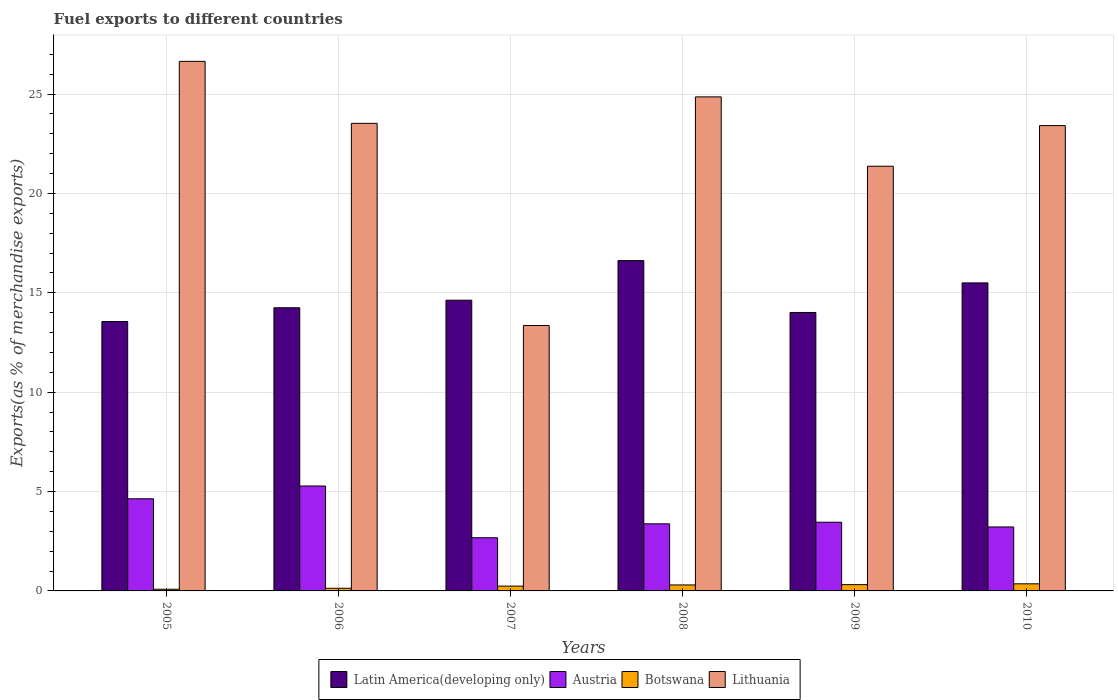How many groups of bars are there?
Your answer should be very brief. 6. Are the number of bars on each tick of the X-axis equal?
Provide a succinct answer. Yes. What is the label of the 4th group of bars from the left?
Offer a very short reply. 2008. In how many cases, is the number of bars for a given year not equal to the number of legend labels?
Make the answer very short. 0. What is the percentage of exports to different countries in Lithuania in 2005?
Offer a terse response. 26.65. Across all years, what is the maximum percentage of exports to different countries in Lithuania?
Your response must be concise. 26.65. Across all years, what is the minimum percentage of exports to different countries in Botswana?
Your answer should be very brief. 0.09. What is the total percentage of exports to different countries in Lithuania in the graph?
Your answer should be compact. 133.18. What is the difference between the percentage of exports to different countries in Botswana in 2007 and that in 2010?
Offer a terse response. -0.12. What is the difference between the percentage of exports to different countries in Botswana in 2008 and the percentage of exports to different countries in Austria in 2009?
Provide a succinct answer. -3.16. What is the average percentage of exports to different countries in Botswana per year?
Ensure brevity in your answer.  0.24. In the year 2005, what is the difference between the percentage of exports to different countries in Lithuania and percentage of exports to different countries in Latin America(developing only)?
Your answer should be very brief. 13.09. In how many years, is the percentage of exports to different countries in Latin America(developing only) greater than 17 %?
Keep it short and to the point. 0. What is the ratio of the percentage of exports to different countries in Latin America(developing only) in 2007 to that in 2009?
Offer a very short reply. 1.04. Is the percentage of exports to different countries in Botswana in 2005 less than that in 2006?
Offer a very short reply. Yes. What is the difference between the highest and the second highest percentage of exports to different countries in Lithuania?
Your answer should be very brief. 1.79. What is the difference between the highest and the lowest percentage of exports to different countries in Austria?
Offer a very short reply. 2.6. Is the sum of the percentage of exports to different countries in Botswana in 2008 and 2010 greater than the maximum percentage of exports to different countries in Lithuania across all years?
Your answer should be compact. No. Is it the case that in every year, the sum of the percentage of exports to different countries in Botswana and percentage of exports to different countries in Latin America(developing only) is greater than the sum of percentage of exports to different countries in Lithuania and percentage of exports to different countries in Austria?
Make the answer very short. No. What does the 1st bar from the left in 2006 represents?
Your answer should be compact. Latin America(developing only). What does the 2nd bar from the right in 2005 represents?
Provide a short and direct response. Botswana. How many bars are there?
Ensure brevity in your answer.  24. What is the difference between two consecutive major ticks on the Y-axis?
Make the answer very short. 5. Are the values on the major ticks of Y-axis written in scientific E-notation?
Your answer should be compact. No. Does the graph contain grids?
Keep it short and to the point. Yes. How are the legend labels stacked?
Your response must be concise. Horizontal. What is the title of the graph?
Your answer should be very brief. Fuel exports to different countries. What is the label or title of the Y-axis?
Your answer should be very brief. Exports(as % of merchandise exports). What is the Exports(as % of merchandise exports) of Latin America(developing only) in 2005?
Your answer should be very brief. 13.56. What is the Exports(as % of merchandise exports) of Austria in 2005?
Your answer should be compact. 4.64. What is the Exports(as % of merchandise exports) of Botswana in 2005?
Your answer should be very brief. 0.09. What is the Exports(as % of merchandise exports) of Lithuania in 2005?
Give a very brief answer. 26.65. What is the Exports(as % of merchandise exports) in Latin America(developing only) in 2006?
Provide a short and direct response. 14.25. What is the Exports(as % of merchandise exports) in Austria in 2006?
Ensure brevity in your answer.  5.28. What is the Exports(as % of merchandise exports) in Botswana in 2006?
Ensure brevity in your answer.  0.13. What is the Exports(as % of merchandise exports) of Lithuania in 2006?
Provide a succinct answer. 23.53. What is the Exports(as % of merchandise exports) of Latin America(developing only) in 2007?
Offer a terse response. 14.63. What is the Exports(as % of merchandise exports) of Austria in 2007?
Provide a succinct answer. 2.67. What is the Exports(as % of merchandise exports) in Botswana in 2007?
Ensure brevity in your answer.  0.24. What is the Exports(as % of merchandise exports) in Lithuania in 2007?
Offer a terse response. 13.36. What is the Exports(as % of merchandise exports) of Latin America(developing only) in 2008?
Give a very brief answer. 16.62. What is the Exports(as % of merchandise exports) of Austria in 2008?
Offer a terse response. 3.38. What is the Exports(as % of merchandise exports) in Botswana in 2008?
Offer a terse response. 0.3. What is the Exports(as % of merchandise exports) in Lithuania in 2008?
Your response must be concise. 24.86. What is the Exports(as % of merchandise exports) in Latin America(developing only) in 2009?
Your answer should be compact. 14.01. What is the Exports(as % of merchandise exports) of Austria in 2009?
Provide a short and direct response. 3.46. What is the Exports(as % of merchandise exports) in Botswana in 2009?
Keep it short and to the point. 0.32. What is the Exports(as % of merchandise exports) of Lithuania in 2009?
Keep it short and to the point. 21.37. What is the Exports(as % of merchandise exports) in Latin America(developing only) in 2010?
Provide a succinct answer. 15.5. What is the Exports(as % of merchandise exports) in Austria in 2010?
Make the answer very short. 3.22. What is the Exports(as % of merchandise exports) in Botswana in 2010?
Ensure brevity in your answer.  0.36. What is the Exports(as % of merchandise exports) in Lithuania in 2010?
Ensure brevity in your answer.  23.41. Across all years, what is the maximum Exports(as % of merchandise exports) of Latin America(developing only)?
Provide a short and direct response. 16.62. Across all years, what is the maximum Exports(as % of merchandise exports) in Austria?
Make the answer very short. 5.28. Across all years, what is the maximum Exports(as % of merchandise exports) in Botswana?
Your response must be concise. 0.36. Across all years, what is the maximum Exports(as % of merchandise exports) of Lithuania?
Provide a short and direct response. 26.65. Across all years, what is the minimum Exports(as % of merchandise exports) of Latin America(developing only)?
Provide a short and direct response. 13.56. Across all years, what is the minimum Exports(as % of merchandise exports) in Austria?
Make the answer very short. 2.67. Across all years, what is the minimum Exports(as % of merchandise exports) in Botswana?
Ensure brevity in your answer.  0.09. Across all years, what is the minimum Exports(as % of merchandise exports) of Lithuania?
Give a very brief answer. 13.36. What is the total Exports(as % of merchandise exports) of Latin America(developing only) in the graph?
Offer a very short reply. 88.56. What is the total Exports(as % of merchandise exports) in Austria in the graph?
Make the answer very short. 22.64. What is the total Exports(as % of merchandise exports) in Botswana in the graph?
Offer a very short reply. 1.43. What is the total Exports(as % of merchandise exports) of Lithuania in the graph?
Provide a succinct answer. 133.18. What is the difference between the Exports(as % of merchandise exports) of Latin America(developing only) in 2005 and that in 2006?
Keep it short and to the point. -0.69. What is the difference between the Exports(as % of merchandise exports) in Austria in 2005 and that in 2006?
Keep it short and to the point. -0.64. What is the difference between the Exports(as % of merchandise exports) in Botswana in 2005 and that in 2006?
Ensure brevity in your answer.  -0.05. What is the difference between the Exports(as % of merchandise exports) in Lithuania in 2005 and that in 2006?
Make the answer very short. 3.12. What is the difference between the Exports(as % of merchandise exports) in Latin America(developing only) in 2005 and that in 2007?
Make the answer very short. -1.07. What is the difference between the Exports(as % of merchandise exports) of Austria in 2005 and that in 2007?
Ensure brevity in your answer.  1.96. What is the difference between the Exports(as % of merchandise exports) of Botswana in 2005 and that in 2007?
Offer a terse response. -0.16. What is the difference between the Exports(as % of merchandise exports) in Lithuania in 2005 and that in 2007?
Provide a succinct answer. 13.29. What is the difference between the Exports(as % of merchandise exports) of Latin America(developing only) in 2005 and that in 2008?
Provide a succinct answer. -3.07. What is the difference between the Exports(as % of merchandise exports) in Austria in 2005 and that in 2008?
Offer a very short reply. 1.26. What is the difference between the Exports(as % of merchandise exports) of Botswana in 2005 and that in 2008?
Make the answer very short. -0.22. What is the difference between the Exports(as % of merchandise exports) of Lithuania in 2005 and that in 2008?
Give a very brief answer. 1.79. What is the difference between the Exports(as % of merchandise exports) of Latin America(developing only) in 2005 and that in 2009?
Your answer should be very brief. -0.46. What is the difference between the Exports(as % of merchandise exports) in Austria in 2005 and that in 2009?
Provide a short and direct response. 1.18. What is the difference between the Exports(as % of merchandise exports) of Botswana in 2005 and that in 2009?
Offer a very short reply. -0.23. What is the difference between the Exports(as % of merchandise exports) in Lithuania in 2005 and that in 2009?
Offer a terse response. 5.28. What is the difference between the Exports(as % of merchandise exports) of Latin America(developing only) in 2005 and that in 2010?
Make the answer very short. -1.94. What is the difference between the Exports(as % of merchandise exports) in Austria in 2005 and that in 2010?
Your answer should be compact. 1.42. What is the difference between the Exports(as % of merchandise exports) in Botswana in 2005 and that in 2010?
Offer a terse response. -0.27. What is the difference between the Exports(as % of merchandise exports) in Lithuania in 2005 and that in 2010?
Provide a short and direct response. 3.23. What is the difference between the Exports(as % of merchandise exports) of Latin America(developing only) in 2006 and that in 2007?
Offer a very short reply. -0.38. What is the difference between the Exports(as % of merchandise exports) of Austria in 2006 and that in 2007?
Keep it short and to the point. 2.6. What is the difference between the Exports(as % of merchandise exports) of Botswana in 2006 and that in 2007?
Provide a succinct answer. -0.11. What is the difference between the Exports(as % of merchandise exports) in Lithuania in 2006 and that in 2007?
Offer a terse response. 10.17. What is the difference between the Exports(as % of merchandise exports) of Latin America(developing only) in 2006 and that in 2008?
Ensure brevity in your answer.  -2.37. What is the difference between the Exports(as % of merchandise exports) of Austria in 2006 and that in 2008?
Your answer should be compact. 1.9. What is the difference between the Exports(as % of merchandise exports) of Botswana in 2006 and that in 2008?
Your answer should be very brief. -0.17. What is the difference between the Exports(as % of merchandise exports) of Lithuania in 2006 and that in 2008?
Your answer should be very brief. -1.33. What is the difference between the Exports(as % of merchandise exports) in Latin America(developing only) in 2006 and that in 2009?
Keep it short and to the point. 0.24. What is the difference between the Exports(as % of merchandise exports) in Austria in 2006 and that in 2009?
Your answer should be very brief. 1.82. What is the difference between the Exports(as % of merchandise exports) of Botswana in 2006 and that in 2009?
Your response must be concise. -0.18. What is the difference between the Exports(as % of merchandise exports) of Lithuania in 2006 and that in 2009?
Offer a terse response. 2.16. What is the difference between the Exports(as % of merchandise exports) in Latin America(developing only) in 2006 and that in 2010?
Offer a terse response. -1.25. What is the difference between the Exports(as % of merchandise exports) of Austria in 2006 and that in 2010?
Your answer should be compact. 2.06. What is the difference between the Exports(as % of merchandise exports) of Botswana in 2006 and that in 2010?
Provide a succinct answer. -0.22. What is the difference between the Exports(as % of merchandise exports) in Lithuania in 2006 and that in 2010?
Your answer should be very brief. 0.11. What is the difference between the Exports(as % of merchandise exports) of Latin America(developing only) in 2007 and that in 2008?
Ensure brevity in your answer.  -1.99. What is the difference between the Exports(as % of merchandise exports) in Austria in 2007 and that in 2008?
Provide a short and direct response. -0.7. What is the difference between the Exports(as % of merchandise exports) of Botswana in 2007 and that in 2008?
Give a very brief answer. -0.06. What is the difference between the Exports(as % of merchandise exports) of Lithuania in 2007 and that in 2008?
Make the answer very short. -11.5. What is the difference between the Exports(as % of merchandise exports) of Latin America(developing only) in 2007 and that in 2009?
Offer a terse response. 0.62. What is the difference between the Exports(as % of merchandise exports) of Austria in 2007 and that in 2009?
Make the answer very short. -0.78. What is the difference between the Exports(as % of merchandise exports) of Botswana in 2007 and that in 2009?
Offer a very short reply. -0.07. What is the difference between the Exports(as % of merchandise exports) in Lithuania in 2007 and that in 2009?
Ensure brevity in your answer.  -8.02. What is the difference between the Exports(as % of merchandise exports) in Latin America(developing only) in 2007 and that in 2010?
Give a very brief answer. -0.87. What is the difference between the Exports(as % of merchandise exports) of Austria in 2007 and that in 2010?
Your answer should be very brief. -0.54. What is the difference between the Exports(as % of merchandise exports) of Botswana in 2007 and that in 2010?
Provide a succinct answer. -0.12. What is the difference between the Exports(as % of merchandise exports) in Lithuania in 2007 and that in 2010?
Give a very brief answer. -10.06. What is the difference between the Exports(as % of merchandise exports) of Latin America(developing only) in 2008 and that in 2009?
Offer a very short reply. 2.61. What is the difference between the Exports(as % of merchandise exports) in Austria in 2008 and that in 2009?
Your answer should be very brief. -0.08. What is the difference between the Exports(as % of merchandise exports) of Botswana in 2008 and that in 2009?
Ensure brevity in your answer.  -0.02. What is the difference between the Exports(as % of merchandise exports) of Lithuania in 2008 and that in 2009?
Your answer should be very brief. 3.49. What is the difference between the Exports(as % of merchandise exports) of Latin America(developing only) in 2008 and that in 2010?
Keep it short and to the point. 1.12. What is the difference between the Exports(as % of merchandise exports) in Austria in 2008 and that in 2010?
Provide a short and direct response. 0.16. What is the difference between the Exports(as % of merchandise exports) in Botswana in 2008 and that in 2010?
Your answer should be very brief. -0.06. What is the difference between the Exports(as % of merchandise exports) of Lithuania in 2008 and that in 2010?
Your answer should be very brief. 1.45. What is the difference between the Exports(as % of merchandise exports) of Latin America(developing only) in 2009 and that in 2010?
Your answer should be compact. -1.49. What is the difference between the Exports(as % of merchandise exports) of Austria in 2009 and that in 2010?
Offer a very short reply. 0.24. What is the difference between the Exports(as % of merchandise exports) of Botswana in 2009 and that in 2010?
Offer a terse response. -0.04. What is the difference between the Exports(as % of merchandise exports) of Lithuania in 2009 and that in 2010?
Give a very brief answer. -2.04. What is the difference between the Exports(as % of merchandise exports) of Latin America(developing only) in 2005 and the Exports(as % of merchandise exports) of Austria in 2006?
Provide a succinct answer. 8.28. What is the difference between the Exports(as % of merchandise exports) in Latin America(developing only) in 2005 and the Exports(as % of merchandise exports) in Botswana in 2006?
Your answer should be compact. 13.42. What is the difference between the Exports(as % of merchandise exports) of Latin America(developing only) in 2005 and the Exports(as % of merchandise exports) of Lithuania in 2006?
Your response must be concise. -9.97. What is the difference between the Exports(as % of merchandise exports) in Austria in 2005 and the Exports(as % of merchandise exports) in Botswana in 2006?
Give a very brief answer. 4.5. What is the difference between the Exports(as % of merchandise exports) of Austria in 2005 and the Exports(as % of merchandise exports) of Lithuania in 2006?
Keep it short and to the point. -18.89. What is the difference between the Exports(as % of merchandise exports) of Botswana in 2005 and the Exports(as % of merchandise exports) of Lithuania in 2006?
Give a very brief answer. -23.44. What is the difference between the Exports(as % of merchandise exports) in Latin America(developing only) in 2005 and the Exports(as % of merchandise exports) in Austria in 2007?
Offer a terse response. 10.88. What is the difference between the Exports(as % of merchandise exports) in Latin America(developing only) in 2005 and the Exports(as % of merchandise exports) in Botswana in 2007?
Make the answer very short. 13.31. What is the difference between the Exports(as % of merchandise exports) in Latin America(developing only) in 2005 and the Exports(as % of merchandise exports) in Lithuania in 2007?
Offer a very short reply. 0.2. What is the difference between the Exports(as % of merchandise exports) in Austria in 2005 and the Exports(as % of merchandise exports) in Botswana in 2007?
Your answer should be compact. 4.39. What is the difference between the Exports(as % of merchandise exports) of Austria in 2005 and the Exports(as % of merchandise exports) of Lithuania in 2007?
Ensure brevity in your answer.  -8.72. What is the difference between the Exports(as % of merchandise exports) in Botswana in 2005 and the Exports(as % of merchandise exports) in Lithuania in 2007?
Offer a very short reply. -13.27. What is the difference between the Exports(as % of merchandise exports) in Latin America(developing only) in 2005 and the Exports(as % of merchandise exports) in Austria in 2008?
Your answer should be very brief. 10.18. What is the difference between the Exports(as % of merchandise exports) of Latin America(developing only) in 2005 and the Exports(as % of merchandise exports) of Botswana in 2008?
Ensure brevity in your answer.  13.26. What is the difference between the Exports(as % of merchandise exports) in Latin America(developing only) in 2005 and the Exports(as % of merchandise exports) in Lithuania in 2008?
Offer a terse response. -11.3. What is the difference between the Exports(as % of merchandise exports) of Austria in 2005 and the Exports(as % of merchandise exports) of Botswana in 2008?
Give a very brief answer. 4.34. What is the difference between the Exports(as % of merchandise exports) of Austria in 2005 and the Exports(as % of merchandise exports) of Lithuania in 2008?
Give a very brief answer. -20.22. What is the difference between the Exports(as % of merchandise exports) in Botswana in 2005 and the Exports(as % of merchandise exports) in Lithuania in 2008?
Offer a terse response. -24.77. What is the difference between the Exports(as % of merchandise exports) of Latin America(developing only) in 2005 and the Exports(as % of merchandise exports) of Austria in 2009?
Keep it short and to the point. 10.1. What is the difference between the Exports(as % of merchandise exports) in Latin America(developing only) in 2005 and the Exports(as % of merchandise exports) in Botswana in 2009?
Your answer should be compact. 13.24. What is the difference between the Exports(as % of merchandise exports) in Latin America(developing only) in 2005 and the Exports(as % of merchandise exports) in Lithuania in 2009?
Provide a short and direct response. -7.82. What is the difference between the Exports(as % of merchandise exports) of Austria in 2005 and the Exports(as % of merchandise exports) of Botswana in 2009?
Ensure brevity in your answer.  4.32. What is the difference between the Exports(as % of merchandise exports) in Austria in 2005 and the Exports(as % of merchandise exports) in Lithuania in 2009?
Your response must be concise. -16.73. What is the difference between the Exports(as % of merchandise exports) of Botswana in 2005 and the Exports(as % of merchandise exports) of Lithuania in 2009?
Offer a very short reply. -21.29. What is the difference between the Exports(as % of merchandise exports) of Latin America(developing only) in 2005 and the Exports(as % of merchandise exports) of Austria in 2010?
Make the answer very short. 10.34. What is the difference between the Exports(as % of merchandise exports) in Latin America(developing only) in 2005 and the Exports(as % of merchandise exports) in Botswana in 2010?
Make the answer very short. 13.2. What is the difference between the Exports(as % of merchandise exports) of Latin America(developing only) in 2005 and the Exports(as % of merchandise exports) of Lithuania in 2010?
Your answer should be compact. -9.86. What is the difference between the Exports(as % of merchandise exports) in Austria in 2005 and the Exports(as % of merchandise exports) in Botswana in 2010?
Offer a terse response. 4.28. What is the difference between the Exports(as % of merchandise exports) of Austria in 2005 and the Exports(as % of merchandise exports) of Lithuania in 2010?
Provide a short and direct response. -18.78. What is the difference between the Exports(as % of merchandise exports) of Botswana in 2005 and the Exports(as % of merchandise exports) of Lithuania in 2010?
Offer a very short reply. -23.33. What is the difference between the Exports(as % of merchandise exports) in Latin America(developing only) in 2006 and the Exports(as % of merchandise exports) in Austria in 2007?
Provide a succinct answer. 11.57. What is the difference between the Exports(as % of merchandise exports) in Latin America(developing only) in 2006 and the Exports(as % of merchandise exports) in Botswana in 2007?
Offer a terse response. 14.01. What is the difference between the Exports(as % of merchandise exports) of Latin America(developing only) in 2006 and the Exports(as % of merchandise exports) of Lithuania in 2007?
Offer a terse response. 0.89. What is the difference between the Exports(as % of merchandise exports) in Austria in 2006 and the Exports(as % of merchandise exports) in Botswana in 2007?
Provide a short and direct response. 5.04. What is the difference between the Exports(as % of merchandise exports) in Austria in 2006 and the Exports(as % of merchandise exports) in Lithuania in 2007?
Your response must be concise. -8.08. What is the difference between the Exports(as % of merchandise exports) in Botswana in 2006 and the Exports(as % of merchandise exports) in Lithuania in 2007?
Provide a short and direct response. -13.22. What is the difference between the Exports(as % of merchandise exports) in Latin America(developing only) in 2006 and the Exports(as % of merchandise exports) in Austria in 2008?
Provide a short and direct response. 10.87. What is the difference between the Exports(as % of merchandise exports) of Latin America(developing only) in 2006 and the Exports(as % of merchandise exports) of Botswana in 2008?
Your answer should be very brief. 13.95. What is the difference between the Exports(as % of merchandise exports) of Latin America(developing only) in 2006 and the Exports(as % of merchandise exports) of Lithuania in 2008?
Make the answer very short. -10.61. What is the difference between the Exports(as % of merchandise exports) of Austria in 2006 and the Exports(as % of merchandise exports) of Botswana in 2008?
Offer a very short reply. 4.98. What is the difference between the Exports(as % of merchandise exports) of Austria in 2006 and the Exports(as % of merchandise exports) of Lithuania in 2008?
Keep it short and to the point. -19.58. What is the difference between the Exports(as % of merchandise exports) of Botswana in 2006 and the Exports(as % of merchandise exports) of Lithuania in 2008?
Keep it short and to the point. -24.73. What is the difference between the Exports(as % of merchandise exports) of Latin America(developing only) in 2006 and the Exports(as % of merchandise exports) of Austria in 2009?
Your answer should be very brief. 10.79. What is the difference between the Exports(as % of merchandise exports) of Latin America(developing only) in 2006 and the Exports(as % of merchandise exports) of Botswana in 2009?
Ensure brevity in your answer.  13.93. What is the difference between the Exports(as % of merchandise exports) in Latin America(developing only) in 2006 and the Exports(as % of merchandise exports) in Lithuania in 2009?
Ensure brevity in your answer.  -7.12. What is the difference between the Exports(as % of merchandise exports) of Austria in 2006 and the Exports(as % of merchandise exports) of Botswana in 2009?
Make the answer very short. 4.96. What is the difference between the Exports(as % of merchandise exports) of Austria in 2006 and the Exports(as % of merchandise exports) of Lithuania in 2009?
Ensure brevity in your answer.  -16.09. What is the difference between the Exports(as % of merchandise exports) of Botswana in 2006 and the Exports(as % of merchandise exports) of Lithuania in 2009?
Offer a very short reply. -21.24. What is the difference between the Exports(as % of merchandise exports) in Latin America(developing only) in 2006 and the Exports(as % of merchandise exports) in Austria in 2010?
Keep it short and to the point. 11.03. What is the difference between the Exports(as % of merchandise exports) of Latin America(developing only) in 2006 and the Exports(as % of merchandise exports) of Botswana in 2010?
Ensure brevity in your answer.  13.89. What is the difference between the Exports(as % of merchandise exports) in Latin America(developing only) in 2006 and the Exports(as % of merchandise exports) in Lithuania in 2010?
Give a very brief answer. -9.17. What is the difference between the Exports(as % of merchandise exports) in Austria in 2006 and the Exports(as % of merchandise exports) in Botswana in 2010?
Keep it short and to the point. 4.92. What is the difference between the Exports(as % of merchandise exports) of Austria in 2006 and the Exports(as % of merchandise exports) of Lithuania in 2010?
Offer a very short reply. -18.14. What is the difference between the Exports(as % of merchandise exports) in Botswana in 2006 and the Exports(as % of merchandise exports) in Lithuania in 2010?
Give a very brief answer. -23.28. What is the difference between the Exports(as % of merchandise exports) in Latin America(developing only) in 2007 and the Exports(as % of merchandise exports) in Austria in 2008?
Offer a terse response. 11.25. What is the difference between the Exports(as % of merchandise exports) in Latin America(developing only) in 2007 and the Exports(as % of merchandise exports) in Botswana in 2008?
Keep it short and to the point. 14.33. What is the difference between the Exports(as % of merchandise exports) of Latin America(developing only) in 2007 and the Exports(as % of merchandise exports) of Lithuania in 2008?
Your answer should be compact. -10.23. What is the difference between the Exports(as % of merchandise exports) in Austria in 2007 and the Exports(as % of merchandise exports) in Botswana in 2008?
Give a very brief answer. 2.37. What is the difference between the Exports(as % of merchandise exports) in Austria in 2007 and the Exports(as % of merchandise exports) in Lithuania in 2008?
Give a very brief answer. -22.19. What is the difference between the Exports(as % of merchandise exports) in Botswana in 2007 and the Exports(as % of merchandise exports) in Lithuania in 2008?
Offer a very short reply. -24.62. What is the difference between the Exports(as % of merchandise exports) in Latin America(developing only) in 2007 and the Exports(as % of merchandise exports) in Austria in 2009?
Give a very brief answer. 11.17. What is the difference between the Exports(as % of merchandise exports) in Latin America(developing only) in 2007 and the Exports(as % of merchandise exports) in Botswana in 2009?
Provide a short and direct response. 14.31. What is the difference between the Exports(as % of merchandise exports) of Latin America(developing only) in 2007 and the Exports(as % of merchandise exports) of Lithuania in 2009?
Offer a terse response. -6.74. What is the difference between the Exports(as % of merchandise exports) in Austria in 2007 and the Exports(as % of merchandise exports) in Botswana in 2009?
Your response must be concise. 2.36. What is the difference between the Exports(as % of merchandise exports) in Austria in 2007 and the Exports(as % of merchandise exports) in Lithuania in 2009?
Ensure brevity in your answer.  -18.7. What is the difference between the Exports(as % of merchandise exports) in Botswana in 2007 and the Exports(as % of merchandise exports) in Lithuania in 2009?
Offer a terse response. -21.13. What is the difference between the Exports(as % of merchandise exports) of Latin America(developing only) in 2007 and the Exports(as % of merchandise exports) of Austria in 2010?
Make the answer very short. 11.41. What is the difference between the Exports(as % of merchandise exports) in Latin America(developing only) in 2007 and the Exports(as % of merchandise exports) in Botswana in 2010?
Offer a very short reply. 14.27. What is the difference between the Exports(as % of merchandise exports) of Latin America(developing only) in 2007 and the Exports(as % of merchandise exports) of Lithuania in 2010?
Offer a terse response. -8.79. What is the difference between the Exports(as % of merchandise exports) in Austria in 2007 and the Exports(as % of merchandise exports) in Botswana in 2010?
Offer a very short reply. 2.32. What is the difference between the Exports(as % of merchandise exports) of Austria in 2007 and the Exports(as % of merchandise exports) of Lithuania in 2010?
Your answer should be very brief. -20.74. What is the difference between the Exports(as % of merchandise exports) of Botswana in 2007 and the Exports(as % of merchandise exports) of Lithuania in 2010?
Your answer should be very brief. -23.17. What is the difference between the Exports(as % of merchandise exports) of Latin America(developing only) in 2008 and the Exports(as % of merchandise exports) of Austria in 2009?
Your answer should be very brief. 13.16. What is the difference between the Exports(as % of merchandise exports) of Latin America(developing only) in 2008 and the Exports(as % of merchandise exports) of Botswana in 2009?
Offer a very short reply. 16.3. What is the difference between the Exports(as % of merchandise exports) of Latin America(developing only) in 2008 and the Exports(as % of merchandise exports) of Lithuania in 2009?
Provide a succinct answer. -4.75. What is the difference between the Exports(as % of merchandise exports) in Austria in 2008 and the Exports(as % of merchandise exports) in Botswana in 2009?
Your answer should be compact. 3.06. What is the difference between the Exports(as % of merchandise exports) of Austria in 2008 and the Exports(as % of merchandise exports) of Lithuania in 2009?
Offer a very short reply. -17.99. What is the difference between the Exports(as % of merchandise exports) of Botswana in 2008 and the Exports(as % of merchandise exports) of Lithuania in 2009?
Your answer should be very brief. -21.07. What is the difference between the Exports(as % of merchandise exports) of Latin America(developing only) in 2008 and the Exports(as % of merchandise exports) of Austria in 2010?
Offer a terse response. 13.4. What is the difference between the Exports(as % of merchandise exports) of Latin America(developing only) in 2008 and the Exports(as % of merchandise exports) of Botswana in 2010?
Provide a succinct answer. 16.26. What is the difference between the Exports(as % of merchandise exports) in Latin America(developing only) in 2008 and the Exports(as % of merchandise exports) in Lithuania in 2010?
Offer a very short reply. -6.79. What is the difference between the Exports(as % of merchandise exports) of Austria in 2008 and the Exports(as % of merchandise exports) of Botswana in 2010?
Give a very brief answer. 3.02. What is the difference between the Exports(as % of merchandise exports) of Austria in 2008 and the Exports(as % of merchandise exports) of Lithuania in 2010?
Your response must be concise. -20.04. What is the difference between the Exports(as % of merchandise exports) of Botswana in 2008 and the Exports(as % of merchandise exports) of Lithuania in 2010?
Offer a terse response. -23.11. What is the difference between the Exports(as % of merchandise exports) in Latin America(developing only) in 2009 and the Exports(as % of merchandise exports) in Austria in 2010?
Ensure brevity in your answer.  10.79. What is the difference between the Exports(as % of merchandise exports) of Latin America(developing only) in 2009 and the Exports(as % of merchandise exports) of Botswana in 2010?
Keep it short and to the point. 13.66. What is the difference between the Exports(as % of merchandise exports) of Latin America(developing only) in 2009 and the Exports(as % of merchandise exports) of Lithuania in 2010?
Your response must be concise. -9.4. What is the difference between the Exports(as % of merchandise exports) in Austria in 2009 and the Exports(as % of merchandise exports) in Botswana in 2010?
Provide a succinct answer. 3.1. What is the difference between the Exports(as % of merchandise exports) in Austria in 2009 and the Exports(as % of merchandise exports) in Lithuania in 2010?
Make the answer very short. -19.96. What is the difference between the Exports(as % of merchandise exports) in Botswana in 2009 and the Exports(as % of merchandise exports) in Lithuania in 2010?
Make the answer very short. -23.1. What is the average Exports(as % of merchandise exports) in Latin America(developing only) per year?
Your answer should be compact. 14.76. What is the average Exports(as % of merchandise exports) of Austria per year?
Make the answer very short. 3.77. What is the average Exports(as % of merchandise exports) in Botswana per year?
Provide a short and direct response. 0.24. What is the average Exports(as % of merchandise exports) of Lithuania per year?
Give a very brief answer. 22.2. In the year 2005, what is the difference between the Exports(as % of merchandise exports) in Latin America(developing only) and Exports(as % of merchandise exports) in Austria?
Ensure brevity in your answer.  8.92. In the year 2005, what is the difference between the Exports(as % of merchandise exports) in Latin America(developing only) and Exports(as % of merchandise exports) in Botswana?
Keep it short and to the point. 13.47. In the year 2005, what is the difference between the Exports(as % of merchandise exports) of Latin America(developing only) and Exports(as % of merchandise exports) of Lithuania?
Provide a succinct answer. -13.09. In the year 2005, what is the difference between the Exports(as % of merchandise exports) in Austria and Exports(as % of merchandise exports) in Botswana?
Give a very brief answer. 4.55. In the year 2005, what is the difference between the Exports(as % of merchandise exports) of Austria and Exports(as % of merchandise exports) of Lithuania?
Ensure brevity in your answer.  -22.01. In the year 2005, what is the difference between the Exports(as % of merchandise exports) of Botswana and Exports(as % of merchandise exports) of Lithuania?
Keep it short and to the point. -26.56. In the year 2006, what is the difference between the Exports(as % of merchandise exports) of Latin America(developing only) and Exports(as % of merchandise exports) of Austria?
Provide a succinct answer. 8.97. In the year 2006, what is the difference between the Exports(as % of merchandise exports) in Latin America(developing only) and Exports(as % of merchandise exports) in Botswana?
Provide a succinct answer. 14.11. In the year 2006, what is the difference between the Exports(as % of merchandise exports) of Latin America(developing only) and Exports(as % of merchandise exports) of Lithuania?
Make the answer very short. -9.28. In the year 2006, what is the difference between the Exports(as % of merchandise exports) of Austria and Exports(as % of merchandise exports) of Botswana?
Make the answer very short. 5.15. In the year 2006, what is the difference between the Exports(as % of merchandise exports) in Austria and Exports(as % of merchandise exports) in Lithuania?
Provide a short and direct response. -18.25. In the year 2006, what is the difference between the Exports(as % of merchandise exports) in Botswana and Exports(as % of merchandise exports) in Lithuania?
Provide a succinct answer. -23.39. In the year 2007, what is the difference between the Exports(as % of merchandise exports) in Latin America(developing only) and Exports(as % of merchandise exports) in Austria?
Offer a terse response. 11.95. In the year 2007, what is the difference between the Exports(as % of merchandise exports) in Latin America(developing only) and Exports(as % of merchandise exports) in Botswana?
Give a very brief answer. 14.39. In the year 2007, what is the difference between the Exports(as % of merchandise exports) of Latin America(developing only) and Exports(as % of merchandise exports) of Lithuania?
Give a very brief answer. 1.27. In the year 2007, what is the difference between the Exports(as % of merchandise exports) in Austria and Exports(as % of merchandise exports) in Botswana?
Ensure brevity in your answer.  2.43. In the year 2007, what is the difference between the Exports(as % of merchandise exports) of Austria and Exports(as % of merchandise exports) of Lithuania?
Give a very brief answer. -10.68. In the year 2007, what is the difference between the Exports(as % of merchandise exports) in Botswana and Exports(as % of merchandise exports) in Lithuania?
Make the answer very short. -13.11. In the year 2008, what is the difference between the Exports(as % of merchandise exports) in Latin America(developing only) and Exports(as % of merchandise exports) in Austria?
Ensure brevity in your answer.  13.24. In the year 2008, what is the difference between the Exports(as % of merchandise exports) in Latin America(developing only) and Exports(as % of merchandise exports) in Botswana?
Give a very brief answer. 16.32. In the year 2008, what is the difference between the Exports(as % of merchandise exports) in Latin America(developing only) and Exports(as % of merchandise exports) in Lithuania?
Provide a short and direct response. -8.24. In the year 2008, what is the difference between the Exports(as % of merchandise exports) in Austria and Exports(as % of merchandise exports) in Botswana?
Give a very brief answer. 3.08. In the year 2008, what is the difference between the Exports(as % of merchandise exports) in Austria and Exports(as % of merchandise exports) in Lithuania?
Give a very brief answer. -21.48. In the year 2008, what is the difference between the Exports(as % of merchandise exports) in Botswana and Exports(as % of merchandise exports) in Lithuania?
Provide a succinct answer. -24.56. In the year 2009, what is the difference between the Exports(as % of merchandise exports) of Latin America(developing only) and Exports(as % of merchandise exports) of Austria?
Provide a short and direct response. 10.56. In the year 2009, what is the difference between the Exports(as % of merchandise exports) in Latin America(developing only) and Exports(as % of merchandise exports) in Botswana?
Ensure brevity in your answer.  13.7. In the year 2009, what is the difference between the Exports(as % of merchandise exports) in Latin America(developing only) and Exports(as % of merchandise exports) in Lithuania?
Your response must be concise. -7.36. In the year 2009, what is the difference between the Exports(as % of merchandise exports) of Austria and Exports(as % of merchandise exports) of Botswana?
Offer a very short reply. 3.14. In the year 2009, what is the difference between the Exports(as % of merchandise exports) of Austria and Exports(as % of merchandise exports) of Lithuania?
Your answer should be compact. -17.91. In the year 2009, what is the difference between the Exports(as % of merchandise exports) of Botswana and Exports(as % of merchandise exports) of Lithuania?
Keep it short and to the point. -21.05. In the year 2010, what is the difference between the Exports(as % of merchandise exports) in Latin America(developing only) and Exports(as % of merchandise exports) in Austria?
Give a very brief answer. 12.28. In the year 2010, what is the difference between the Exports(as % of merchandise exports) of Latin America(developing only) and Exports(as % of merchandise exports) of Botswana?
Your answer should be very brief. 15.14. In the year 2010, what is the difference between the Exports(as % of merchandise exports) in Latin America(developing only) and Exports(as % of merchandise exports) in Lithuania?
Offer a terse response. -7.92. In the year 2010, what is the difference between the Exports(as % of merchandise exports) of Austria and Exports(as % of merchandise exports) of Botswana?
Offer a terse response. 2.86. In the year 2010, what is the difference between the Exports(as % of merchandise exports) in Austria and Exports(as % of merchandise exports) in Lithuania?
Your answer should be very brief. -20.2. In the year 2010, what is the difference between the Exports(as % of merchandise exports) of Botswana and Exports(as % of merchandise exports) of Lithuania?
Give a very brief answer. -23.06. What is the ratio of the Exports(as % of merchandise exports) of Latin America(developing only) in 2005 to that in 2006?
Your answer should be very brief. 0.95. What is the ratio of the Exports(as % of merchandise exports) of Austria in 2005 to that in 2006?
Your answer should be compact. 0.88. What is the ratio of the Exports(as % of merchandise exports) of Botswana in 2005 to that in 2006?
Provide a succinct answer. 0.64. What is the ratio of the Exports(as % of merchandise exports) in Lithuania in 2005 to that in 2006?
Offer a terse response. 1.13. What is the ratio of the Exports(as % of merchandise exports) of Latin America(developing only) in 2005 to that in 2007?
Keep it short and to the point. 0.93. What is the ratio of the Exports(as % of merchandise exports) of Austria in 2005 to that in 2007?
Offer a very short reply. 1.73. What is the ratio of the Exports(as % of merchandise exports) in Botswana in 2005 to that in 2007?
Your answer should be very brief. 0.35. What is the ratio of the Exports(as % of merchandise exports) in Lithuania in 2005 to that in 2007?
Offer a very short reply. 2. What is the ratio of the Exports(as % of merchandise exports) of Latin America(developing only) in 2005 to that in 2008?
Offer a very short reply. 0.82. What is the ratio of the Exports(as % of merchandise exports) in Austria in 2005 to that in 2008?
Offer a very short reply. 1.37. What is the ratio of the Exports(as % of merchandise exports) in Botswana in 2005 to that in 2008?
Your answer should be very brief. 0.28. What is the ratio of the Exports(as % of merchandise exports) in Lithuania in 2005 to that in 2008?
Provide a succinct answer. 1.07. What is the ratio of the Exports(as % of merchandise exports) in Latin America(developing only) in 2005 to that in 2009?
Your response must be concise. 0.97. What is the ratio of the Exports(as % of merchandise exports) of Austria in 2005 to that in 2009?
Ensure brevity in your answer.  1.34. What is the ratio of the Exports(as % of merchandise exports) in Botswana in 2005 to that in 2009?
Your answer should be compact. 0.27. What is the ratio of the Exports(as % of merchandise exports) in Lithuania in 2005 to that in 2009?
Your answer should be very brief. 1.25. What is the ratio of the Exports(as % of merchandise exports) of Latin America(developing only) in 2005 to that in 2010?
Ensure brevity in your answer.  0.87. What is the ratio of the Exports(as % of merchandise exports) of Austria in 2005 to that in 2010?
Offer a terse response. 1.44. What is the ratio of the Exports(as % of merchandise exports) of Botswana in 2005 to that in 2010?
Provide a succinct answer. 0.24. What is the ratio of the Exports(as % of merchandise exports) in Lithuania in 2005 to that in 2010?
Your answer should be very brief. 1.14. What is the ratio of the Exports(as % of merchandise exports) in Latin America(developing only) in 2006 to that in 2007?
Ensure brevity in your answer.  0.97. What is the ratio of the Exports(as % of merchandise exports) in Austria in 2006 to that in 2007?
Provide a succinct answer. 1.97. What is the ratio of the Exports(as % of merchandise exports) of Botswana in 2006 to that in 2007?
Make the answer very short. 0.55. What is the ratio of the Exports(as % of merchandise exports) of Lithuania in 2006 to that in 2007?
Keep it short and to the point. 1.76. What is the ratio of the Exports(as % of merchandise exports) of Latin America(developing only) in 2006 to that in 2008?
Offer a very short reply. 0.86. What is the ratio of the Exports(as % of merchandise exports) of Austria in 2006 to that in 2008?
Ensure brevity in your answer.  1.56. What is the ratio of the Exports(as % of merchandise exports) in Botswana in 2006 to that in 2008?
Your response must be concise. 0.44. What is the ratio of the Exports(as % of merchandise exports) of Lithuania in 2006 to that in 2008?
Keep it short and to the point. 0.95. What is the ratio of the Exports(as % of merchandise exports) of Latin America(developing only) in 2006 to that in 2009?
Provide a succinct answer. 1.02. What is the ratio of the Exports(as % of merchandise exports) in Austria in 2006 to that in 2009?
Give a very brief answer. 1.53. What is the ratio of the Exports(as % of merchandise exports) of Botswana in 2006 to that in 2009?
Offer a terse response. 0.42. What is the ratio of the Exports(as % of merchandise exports) in Lithuania in 2006 to that in 2009?
Your answer should be very brief. 1.1. What is the ratio of the Exports(as % of merchandise exports) of Latin America(developing only) in 2006 to that in 2010?
Offer a very short reply. 0.92. What is the ratio of the Exports(as % of merchandise exports) of Austria in 2006 to that in 2010?
Your answer should be very brief. 1.64. What is the ratio of the Exports(as % of merchandise exports) in Botswana in 2006 to that in 2010?
Provide a succinct answer. 0.37. What is the ratio of the Exports(as % of merchandise exports) of Latin America(developing only) in 2007 to that in 2008?
Your answer should be very brief. 0.88. What is the ratio of the Exports(as % of merchandise exports) in Austria in 2007 to that in 2008?
Keep it short and to the point. 0.79. What is the ratio of the Exports(as % of merchandise exports) of Botswana in 2007 to that in 2008?
Make the answer very short. 0.81. What is the ratio of the Exports(as % of merchandise exports) of Lithuania in 2007 to that in 2008?
Your response must be concise. 0.54. What is the ratio of the Exports(as % of merchandise exports) in Latin America(developing only) in 2007 to that in 2009?
Provide a succinct answer. 1.04. What is the ratio of the Exports(as % of merchandise exports) of Austria in 2007 to that in 2009?
Your answer should be compact. 0.77. What is the ratio of the Exports(as % of merchandise exports) of Botswana in 2007 to that in 2009?
Your answer should be very brief. 0.77. What is the ratio of the Exports(as % of merchandise exports) of Lithuania in 2007 to that in 2009?
Give a very brief answer. 0.62. What is the ratio of the Exports(as % of merchandise exports) in Latin America(developing only) in 2007 to that in 2010?
Offer a terse response. 0.94. What is the ratio of the Exports(as % of merchandise exports) of Austria in 2007 to that in 2010?
Provide a succinct answer. 0.83. What is the ratio of the Exports(as % of merchandise exports) in Botswana in 2007 to that in 2010?
Provide a short and direct response. 0.68. What is the ratio of the Exports(as % of merchandise exports) in Lithuania in 2007 to that in 2010?
Your answer should be compact. 0.57. What is the ratio of the Exports(as % of merchandise exports) in Latin America(developing only) in 2008 to that in 2009?
Offer a terse response. 1.19. What is the ratio of the Exports(as % of merchandise exports) of Austria in 2008 to that in 2009?
Make the answer very short. 0.98. What is the ratio of the Exports(as % of merchandise exports) in Botswana in 2008 to that in 2009?
Offer a terse response. 0.95. What is the ratio of the Exports(as % of merchandise exports) in Lithuania in 2008 to that in 2009?
Keep it short and to the point. 1.16. What is the ratio of the Exports(as % of merchandise exports) in Latin America(developing only) in 2008 to that in 2010?
Provide a succinct answer. 1.07. What is the ratio of the Exports(as % of merchandise exports) of Austria in 2008 to that in 2010?
Make the answer very short. 1.05. What is the ratio of the Exports(as % of merchandise exports) in Botswana in 2008 to that in 2010?
Offer a terse response. 0.84. What is the ratio of the Exports(as % of merchandise exports) of Lithuania in 2008 to that in 2010?
Your answer should be very brief. 1.06. What is the ratio of the Exports(as % of merchandise exports) of Latin America(developing only) in 2009 to that in 2010?
Your response must be concise. 0.9. What is the ratio of the Exports(as % of merchandise exports) of Austria in 2009 to that in 2010?
Keep it short and to the point. 1.07. What is the ratio of the Exports(as % of merchandise exports) of Botswana in 2009 to that in 2010?
Your response must be concise. 0.88. What is the ratio of the Exports(as % of merchandise exports) of Lithuania in 2009 to that in 2010?
Offer a very short reply. 0.91. What is the difference between the highest and the second highest Exports(as % of merchandise exports) in Latin America(developing only)?
Your answer should be compact. 1.12. What is the difference between the highest and the second highest Exports(as % of merchandise exports) in Austria?
Your answer should be compact. 0.64. What is the difference between the highest and the second highest Exports(as % of merchandise exports) in Botswana?
Provide a short and direct response. 0.04. What is the difference between the highest and the second highest Exports(as % of merchandise exports) of Lithuania?
Make the answer very short. 1.79. What is the difference between the highest and the lowest Exports(as % of merchandise exports) of Latin America(developing only)?
Your answer should be very brief. 3.07. What is the difference between the highest and the lowest Exports(as % of merchandise exports) in Austria?
Provide a short and direct response. 2.6. What is the difference between the highest and the lowest Exports(as % of merchandise exports) in Botswana?
Offer a very short reply. 0.27. What is the difference between the highest and the lowest Exports(as % of merchandise exports) of Lithuania?
Keep it short and to the point. 13.29. 